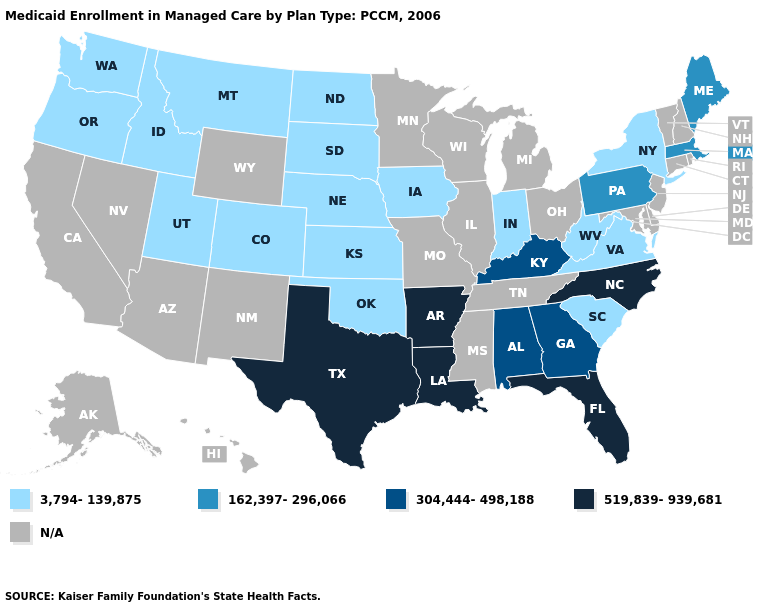What is the value of Maryland?
Keep it brief. N/A. Is the legend a continuous bar?
Be succinct. No. What is the lowest value in the Northeast?
Write a very short answer. 3,794-139,875. What is the value of Illinois?
Keep it brief. N/A. Name the states that have a value in the range N/A?
Answer briefly. Alaska, Arizona, California, Connecticut, Delaware, Hawaii, Illinois, Maryland, Michigan, Minnesota, Mississippi, Missouri, Nevada, New Hampshire, New Jersey, New Mexico, Ohio, Rhode Island, Tennessee, Vermont, Wisconsin, Wyoming. Name the states that have a value in the range 3,794-139,875?
Short answer required. Colorado, Idaho, Indiana, Iowa, Kansas, Montana, Nebraska, New York, North Dakota, Oklahoma, Oregon, South Carolina, South Dakota, Utah, Virginia, Washington, West Virginia. What is the value of Iowa?
Answer briefly. 3,794-139,875. Is the legend a continuous bar?
Short answer required. No. What is the lowest value in the USA?
Give a very brief answer. 3,794-139,875. Does the map have missing data?
Concise answer only. Yes. Name the states that have a value in the range 3,794-139,875?
Be succinct. Colorado, Idaho, Indiana, Iowa, Kansas, Montana, Nebraska, New York, North Dakota, Oklahoma, Oregon, South Carolina, South Dakota, Utah, Virginia, Washington, West Virginia. Name the states that have a value in the range 519,839-939,681?
Write a very short answer. Arkansas, Florida, Louisiana, North Carolina, Texas. Does Arkansas have the highest value in the USA?
Write a very short answer. Yes. 